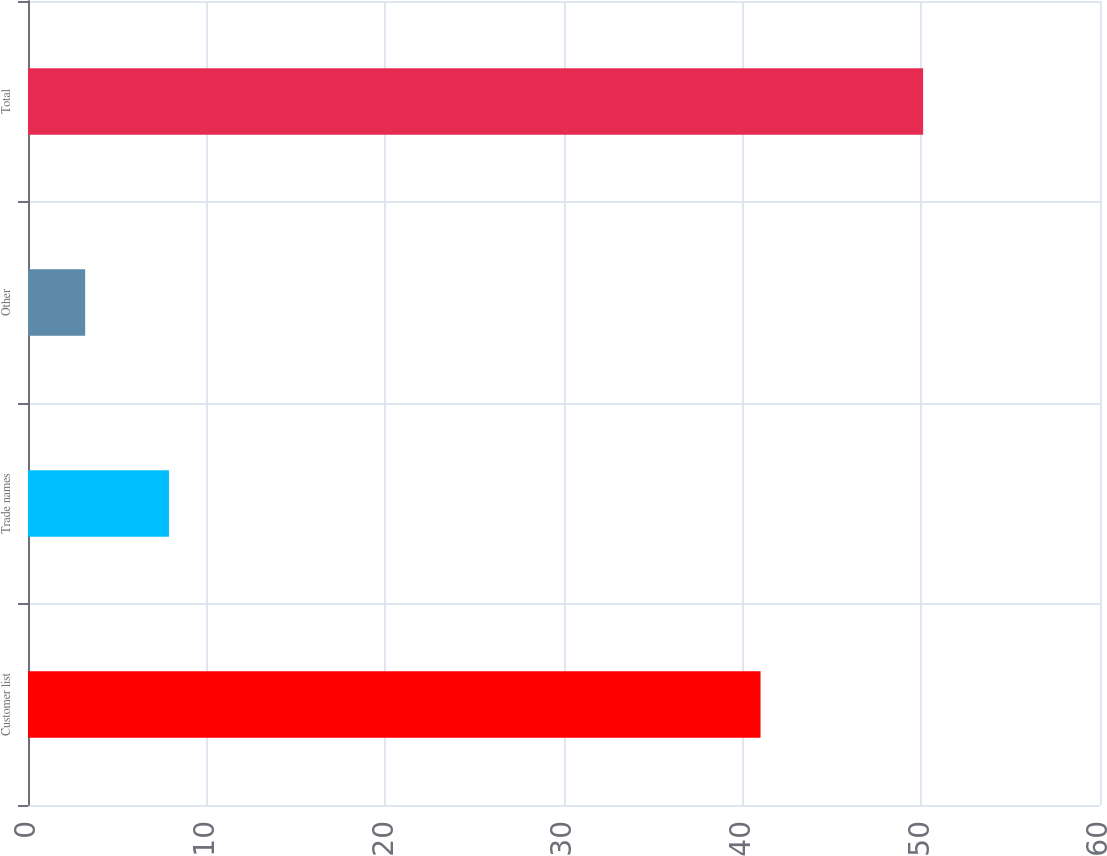<chart> <loc_0><loc_0><loc_500><loc_500><bar_chart><fcel>Customer list<fcel>Trade names<fcel>Other<fcel>Total<nl><fcel>41<fcel>7.89<fcel>3.2<fcel>50.1<nl></chart> 